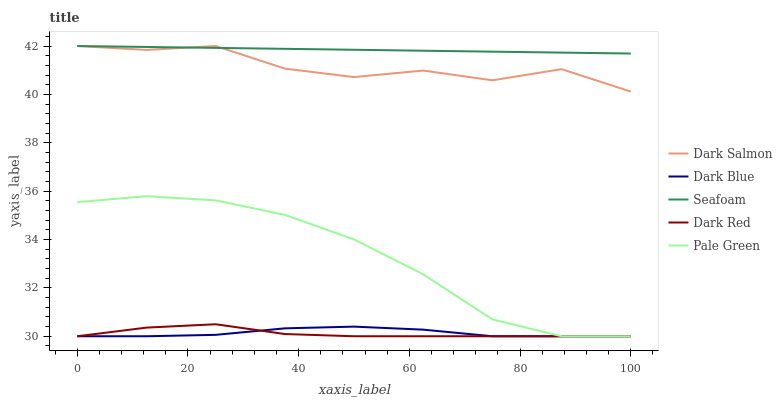Does Dark Red have the minimum area under the curve?
Answer yes or no. Yes. Does Seafoam have the maximum area under the curve?
Answer yes or no. Yes. Does Pale Green have the minimum area under the curve?
Answer yes or no. No. Does Pale Green have the maximum area under the curve?
Answer yes or no. No. Is Seafoam the smoothest?
Answer yes or no. Yes. Is Dark Salmon the roughest?
Answer yes or no. Yes. Is Pale Green the smoothest?
Answer yes or no. No. Is Pale Green the roughest?
Answer yes or no. No. Does Dark Blue have the lowest value?
Answer yes or no. Yes. Does Dark Salmon have the lowest value?
Answer yes or no. No. Does Seafoam have the highest value?
Answer yes or no. Yes. Does Pale Green have the highest value?
Answer yes or no. No. Is Dark Blue less than Dark Salmon?
Answer yes or no. Yes. Is Seafoam greater than Dark Red?
Answer yes or no. Yes. Does Dark Salmon intersect Seafoam?
Answer yes or no. Yes. Is Dark Salmon less than Seafoam?
Answer yes or no. No. Is Dark Salmon greater than Seafoam?
Answer yes or no. No. Does Dark Blue intersect Dark Salmon?
Answer yes or no. No. 